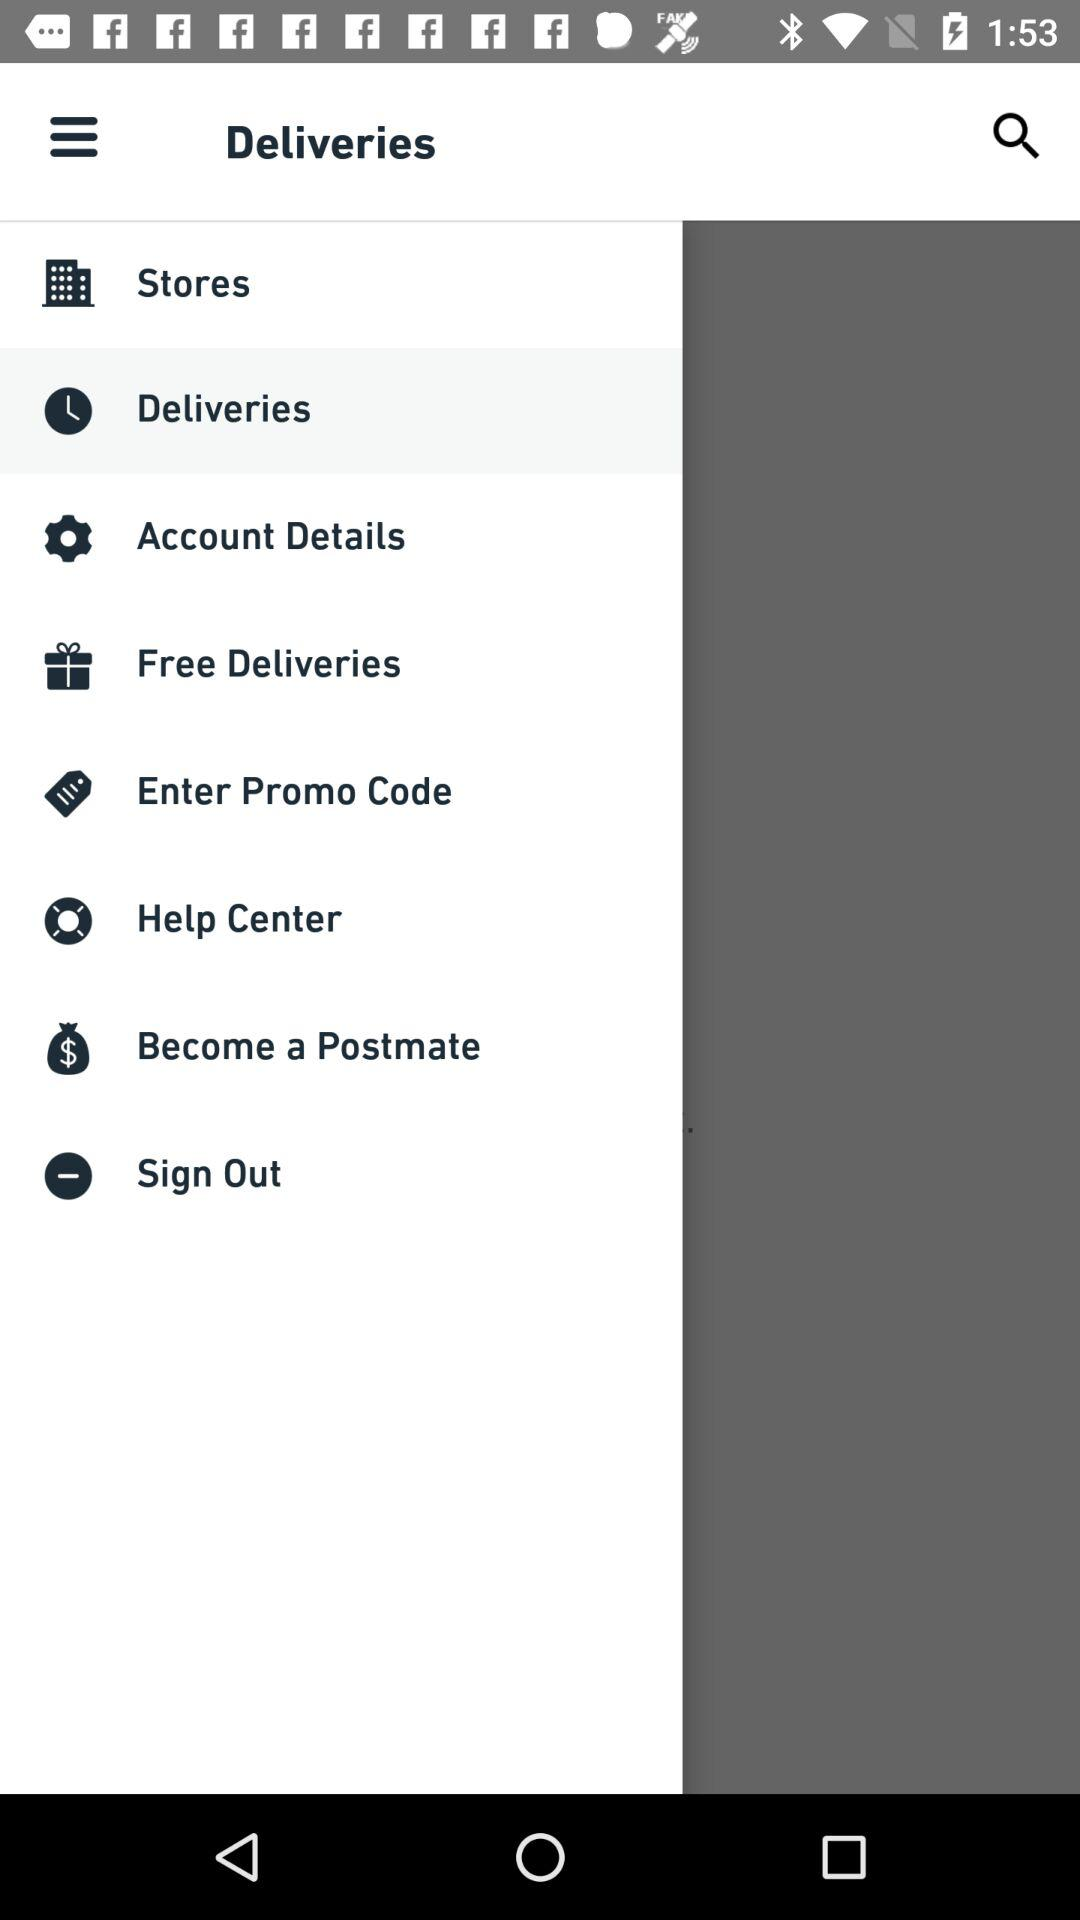How does someone become a "Postmate"?
When the provided information is insufficient, respond with <no answer>. <no answer> 